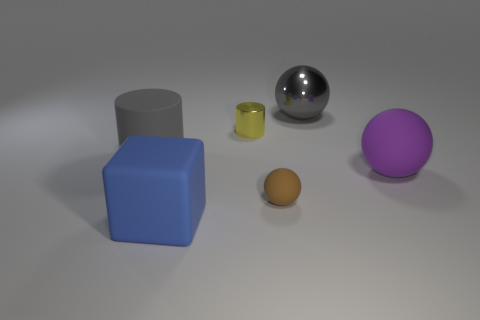Add 1 big blue rubber blocks. How many objects exist? 7 Subtract all cylinders. How many objects are left? 4 Subtract all large metallic cylinders. Subtract all balls. How many objects are left? 3 Add 2 brown balls. How many brown balls are left? 3 Add 1 small yellow metallic objects. How many small yellow metallic objects exist? 2 Subtract 1 purple spheres. How many objects are left? 5 